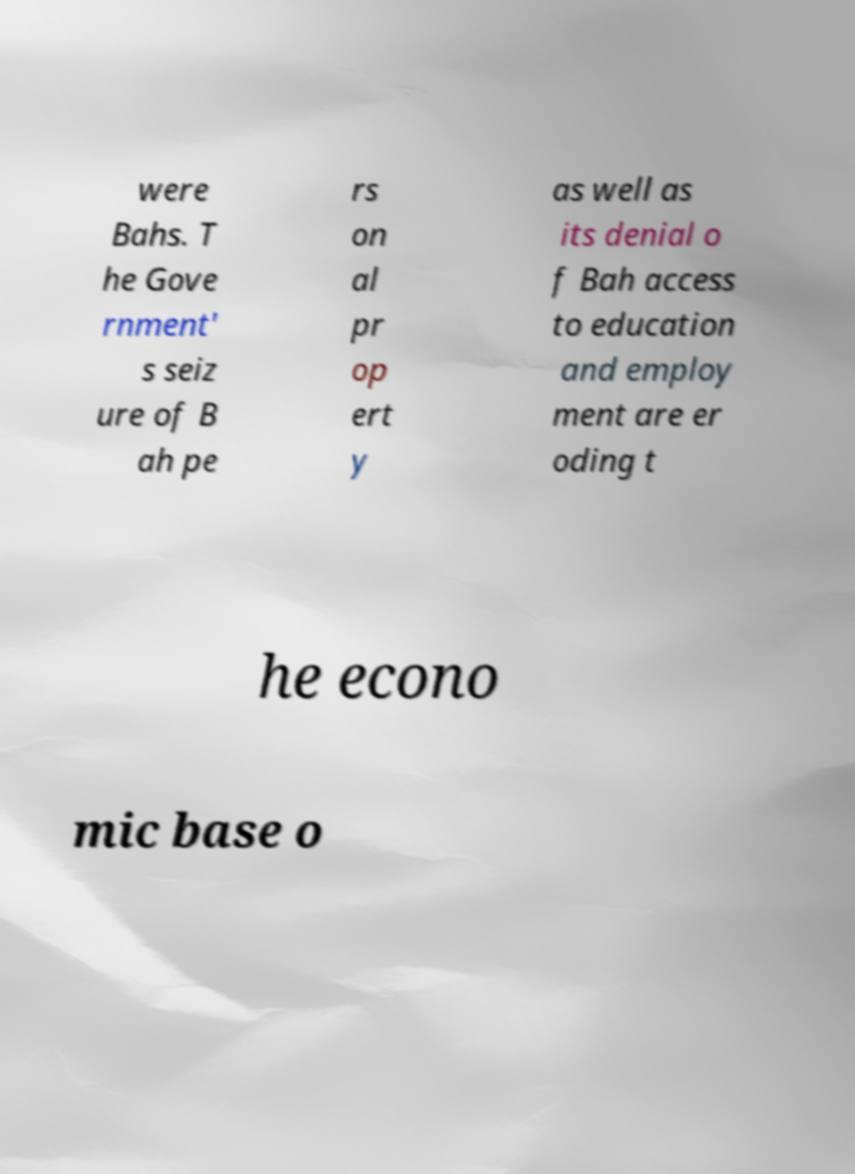Can you read and provide the text displayed in the image?This photo seems to have some interesting text. Can you extract and type it out for me? were Bahs. T he Gove rnment' s seiz ure of B ah pe rs on al pr op ert y as well as its denial o f Bah access to education and employ ment are er oding t he econo mic base o 